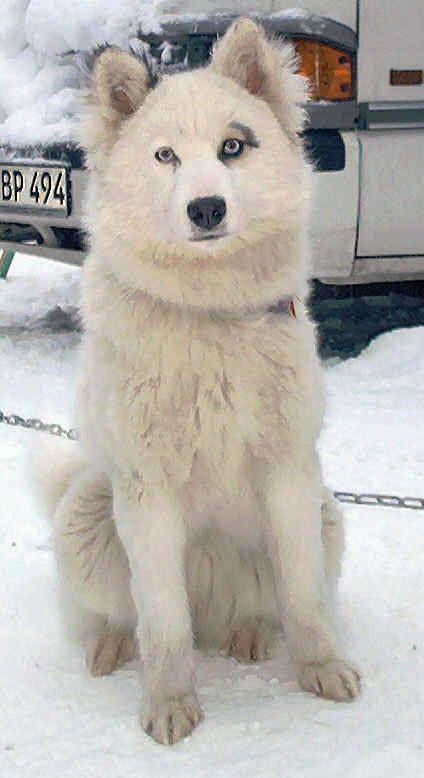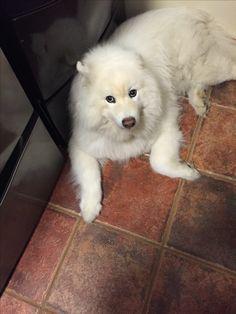The first image is the image on the left, the second image is the image on the right. Evaluate the accuracy of this statement regarding the images: "There are three dogs.". Is it true? Answer yes or no. No. 